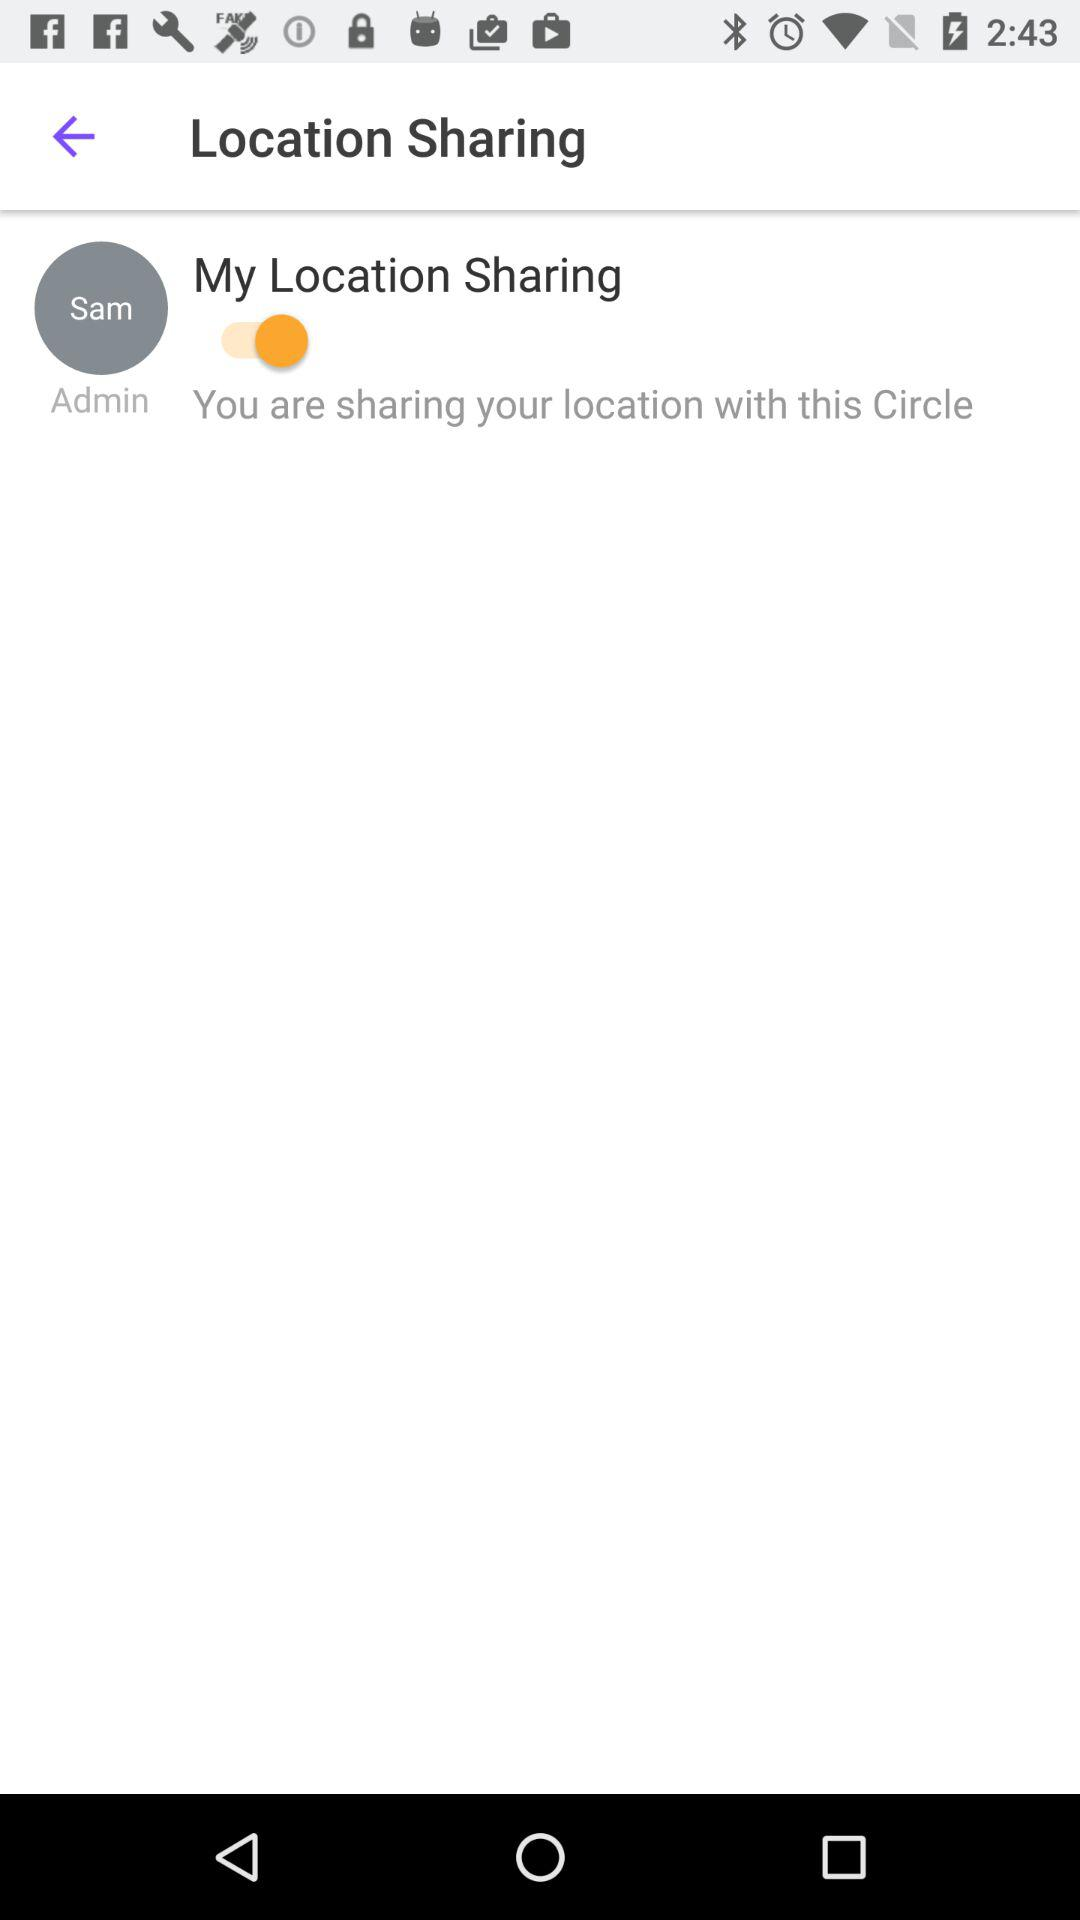Who is the admin? The admin is Sam. 